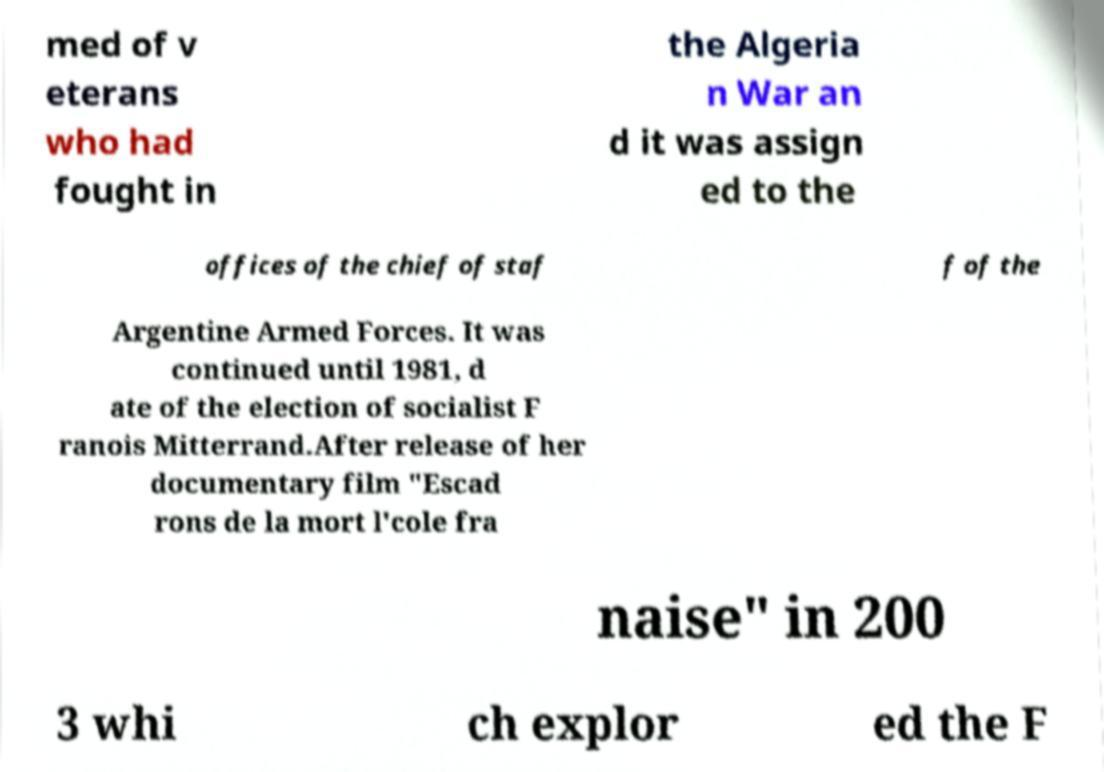Please identify and transcribe the text found in this image. med of v eterans who had fought in the Algeria n War an d it was assign ed to the offices of the chief of staf f of the Argentine Armed Forces. It was continued until 1981, d ate of the election of socialist F ranois Mitterrand.After release of her documentary film "Escad rons de la mort l'cole fra naise" in 200 3 whi ch explor ed the F 